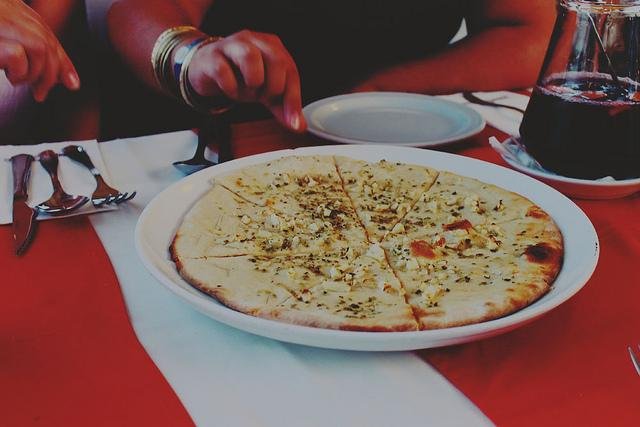What Leavening was used in this dish? Please explain your reasoning. yeast. It is a flat bread with no leavening 